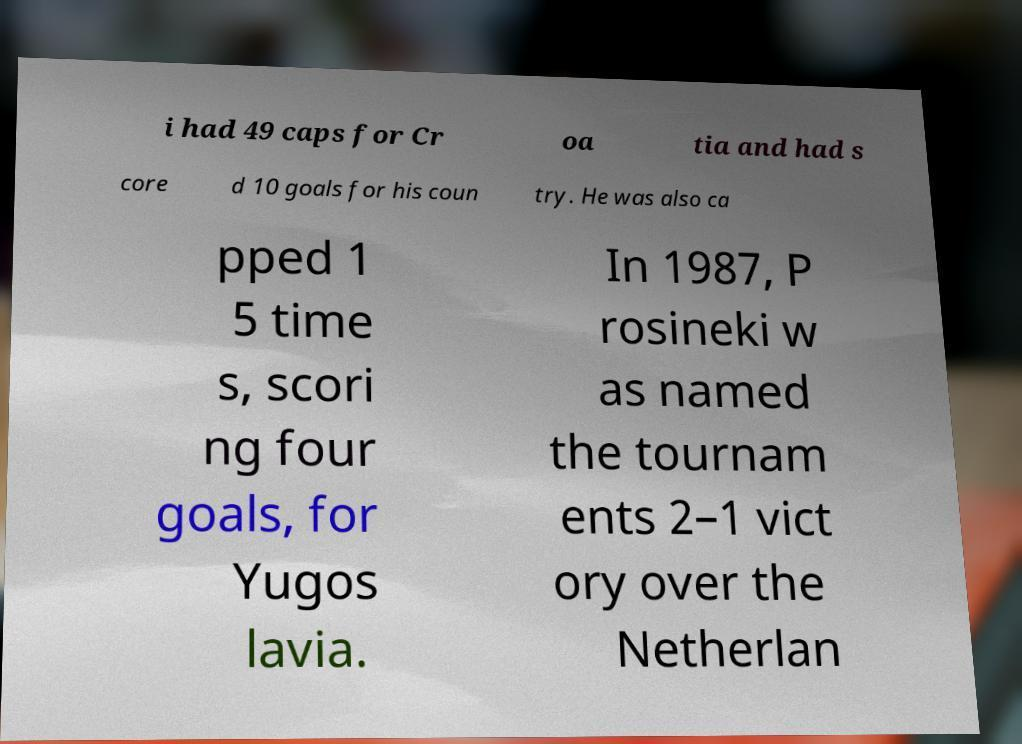Can you read and provide the text displayed in the image?This photo seems to have some interesting text. Can you extract and type it out for me? i had 49 caps for Cr oa tia and had s core d 10 goals for his coun try. He was also ca pped 1 5 time s, scori ng four goals, for Yugos lavia. In 1987, P rosineki w as named the tournam ents 2–1 vict ory over the Netherlan 